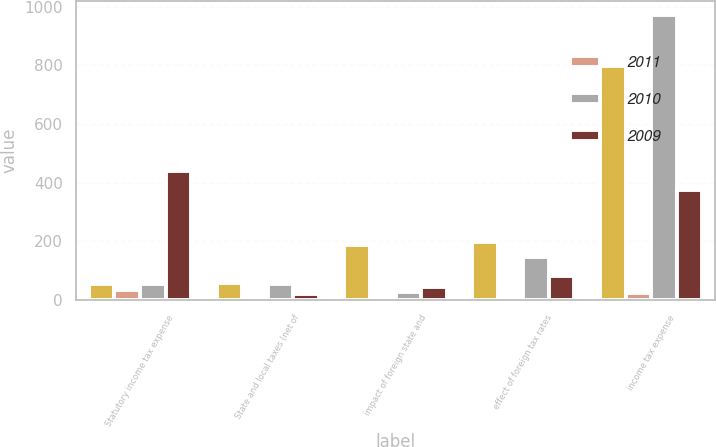<chart> <loc_0><loc_0><loc_500><loc_500><stacked_bar_chart><ecel><fcel>Statutory income tax expense<fcel>State and local taxes (net of<fcel>impact of foreign state and<fcel>effect of foreign tax rates<fcel>income tax expense<nl><fcel>nan<fcel>56<fcel>59<fcel>188<fcel>197<fcel>796<nl><fcel>2011<fcel>35<fcel>2<fcel>6<fcel>6<fcel>25<nl><fcel>2010<fcel>56<fcel>53<fcel>27<fcel>145<fcel>971<nl><fcel>2009<fcel>438<fcel>21<fcel>45<fcel>81<fcel>375<nl></chart> 